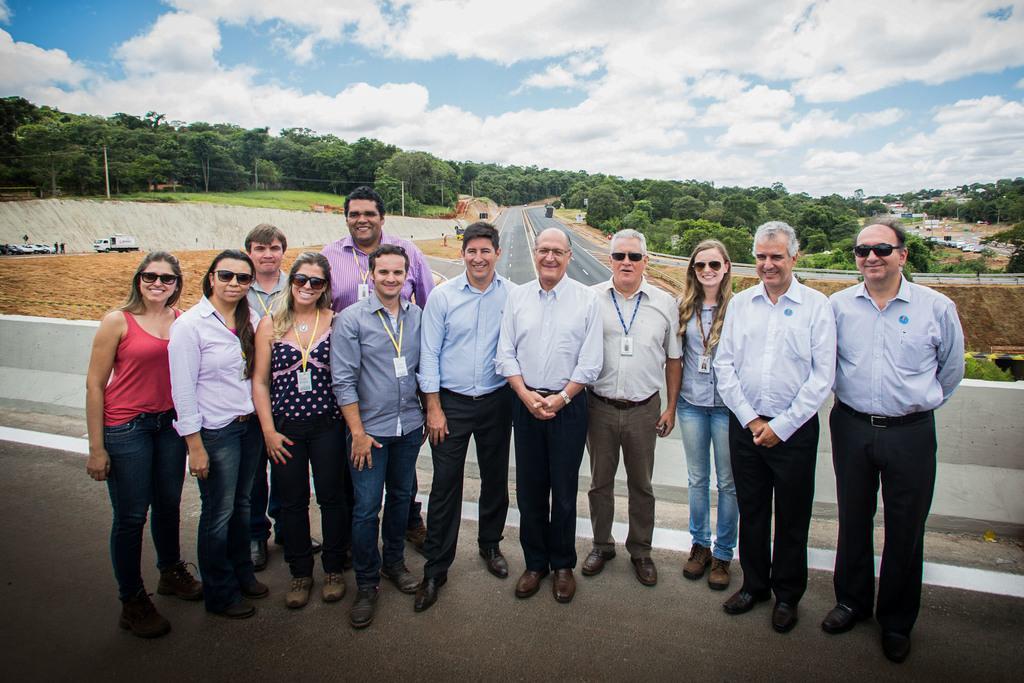In one or two sentences, can you explain what this image depicts? In this image there are people standing on a bridge, in the background there are vehicles roads, trees and the sky. 